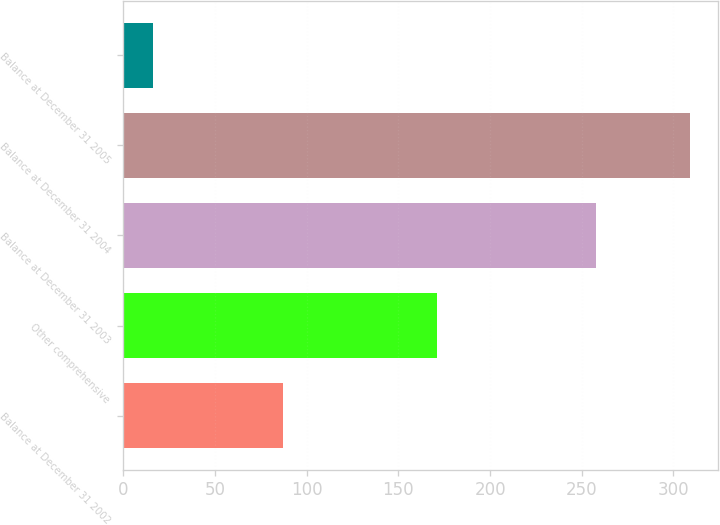<chart> <loc_0><loc_0><loc_500><loc_500><bar_chart><fcel>Balance at December 31 2002<fcel>Other comprehensive<fcel>Balance at December 31 2003<fcel>Balance at December 31 2004<fcel>Balance at December 31 2005<nl><fcel>87<fcel>171<fcel>258<fcel>309<fcel>16<nl></chart> 